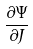<formula> <loc_0><loc_0><loc_500><loc_500>\frac { \partial \Psi } { \partial J }</formula> 